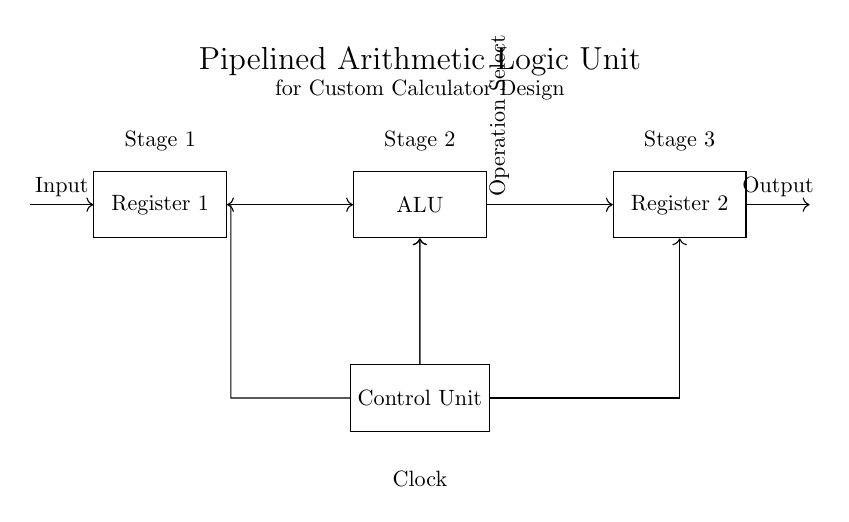What are the components of the circuit? The components include Register 1, ALU, Register 2, and Control Unit, as labeled in the diagram.
Answer: Register 1, ALU, Register 2, Control Unit What is the purpose of the Control Unit in this circuit? The Control Unit manages the operation of the ALU and synchronizes the data flow through the registers using clock signals.
Answer: Manage operation of the ALU How many pipeline stages are there in this design? There are three stages indicated in the diagram corresponding to Register 1, ALU, and Register 2.
Answer: Three What is the direction of data flow between Register 1 and the ALU? The data flows unidirectionally from Register 1 to the ALU, as shown by the arrow connecting these two components.
Answer: Unidirectional What does "Operation Select" indicate in the context of this circuit? "Operation Select" refers to the control signals provided by the Control Unit that determine which arithmetic or logic operation the ALU performs.
Answer: Control signals for ALU operations How is the clock signal distributed in the circuit? The clock signal is sent from the Control Unit to both Register 1 and Register 2, allowing them to synchronize their operation with the ALU.
Answer: Sent to Register 1 and Register 2 What is the role of the output in this circuit? The output represents the result of the operations performed by the ALU, coming from Register 2, which is processed data.
Answer: Result of the operations 